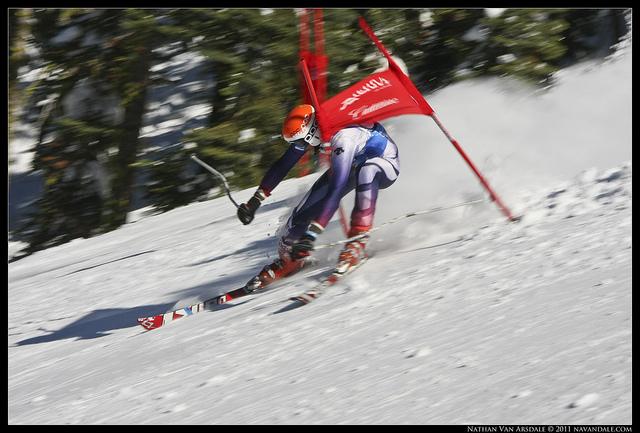What color are the poles in the snow?
Keep it brief. Red. What sport is this?
Quick response, please. Skiing. What color is the flag?
Short answer required. Red. Is this the man's first type on skis?
Keep it brief. No. 